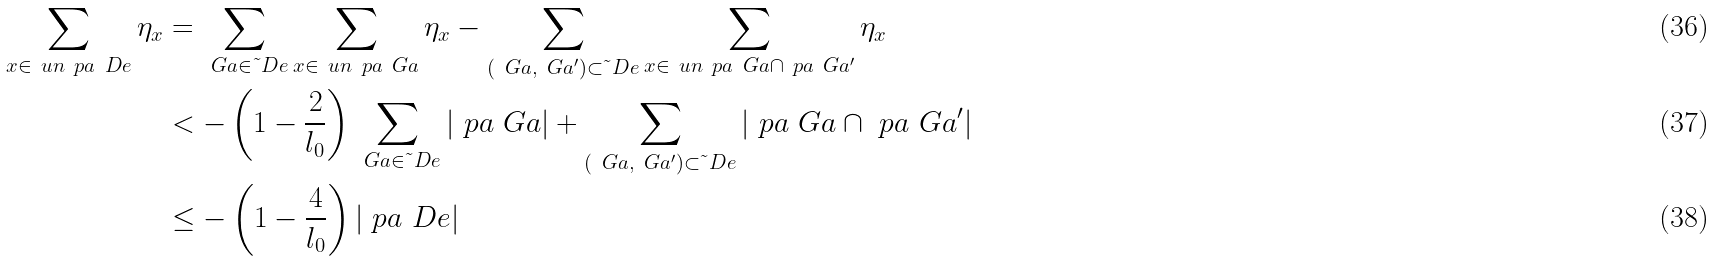<formula> <loc_0><loc_0><loc_500><loc_500>\sum _ { x \in \ u n { \ p a \ D e } } \eta _ { x } & = \sum _ { \ G a \in \tilde { \ } D e } \sum _ { x \in \ u n { \ p a \ G a } } \eta _ { x } - \sum _ { ( \ G a , \ G a ^ { \prime } ) \subset \tilde { \ } D e } \sum _ { x \in \ u n { \ p a \ G a \cap \ p a \ G a ^ { \prime } } } \eta _ { x } \\ & < - \left ( 1 - \frac { 2 } { l _ { 0 } } \right ) \sum _ { \ G a \in \tilde { \ } D e } | \ p a \ G a | + \sum _ { ( \ G a , \ G a ^ { \prime } ) \subset \tilde { \ } D e } | \ p a \ G a \cap \ p a \ G a ^ { \prime } | \\ & \leq - \left ( 1 - \frac { 4 } { l _ { 0 } } \right ) | \ p a \ D e |</formula> 